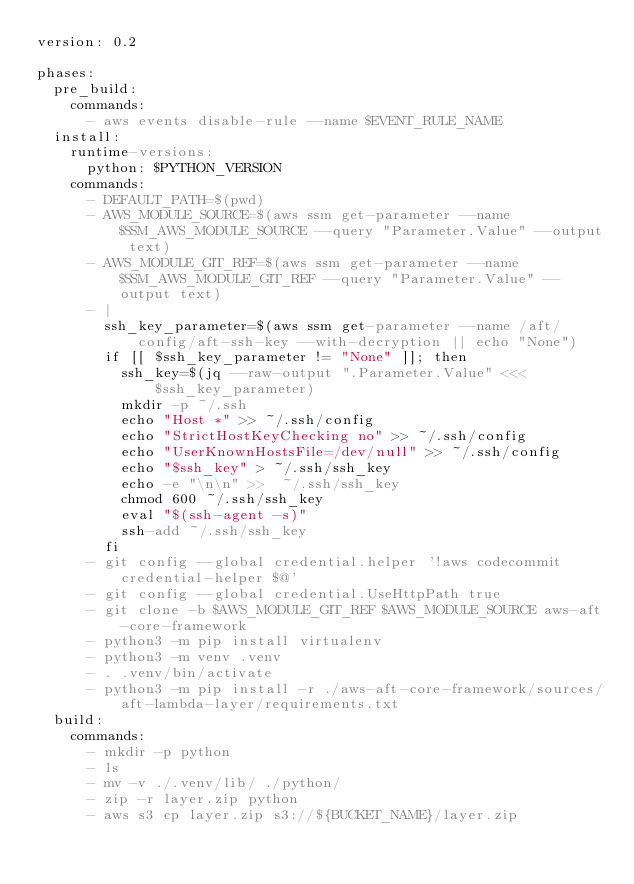<code> <loc_0><loc_0><loc_500><loc_500><_YAML_>version: 0.2

phases:
  pre_build:
    commands:
      - aws events disable-rule --name $EVENT_RULE_NAME
  install:
    runtime-versions:
      python: $PYTHON_VERSION
    commands:
      - DEFAULT_PATH=$(pwd)
      - AWS_MODULE_SOURCE=$(aws ssm get-parameter --name $SSM_AWS_MODULE_SOURCE --query "Parameter.Value" --output text)
      - AWS_MODULE_GIT_REF=$(aws ssm get-parameter --name $SSM_AWS_MODULE_GIT_REF --query "Parameter.Value" --output text)
      - |
        ssh_key_parameter=$(aws ssm get-parameter --name /aft/config/aft-ssh-key --with-decryption || echo "None")
        if [[ $ssh_key_parameter != "None" ]]; then
          ssh_key=$(jq --raw-output ".Parameter.Value" <<< $ssh_key_parameter)
          mkdir -p ~/.ssh
          echo "Host *" >> ~/.ssh/config
          echo "StrictHostKeyChecking no" >> ~/.ssh/config
          echo "UserKnownHostsFile=/dev/null" >> ~/.ssh/config
          echo "$ssh_key" > ~/.ssh/ssh_key
          echo -e "\n\n" >>  ~/.ssh/ssh_key
          chmod 600 ~/.ssh/ssh_key
          eval "$(ssh-agent -s)"
          ssh-add ~/.ssh/ssh_key
        fi
      - git config --global credential.helper '!aws codecommit credential-helper $@'
      - git config --global credential.UseHttpPath true
      - git clone -b $AWS_MODULE_GIT_REF $AWS_MODULE_SOURCE aws-aft-core-framework
      - python3 -m pip install virtualenv
      - python3 -m venv .venv
      - . .venv/bin/activate
      - python3 -m pip install -r ./aws-aft-core-framework/sources/aft-lambda-layer/requirements.txt
  build:
    commands:
      - mkdir -p python
      - ls
      - mv -v ./.venv/lib/ ./python/
      - zip -r layer.zip python
      - aws s3 cp layer.zip s3://${BUCKET_NAME}/layer.zip</code> 